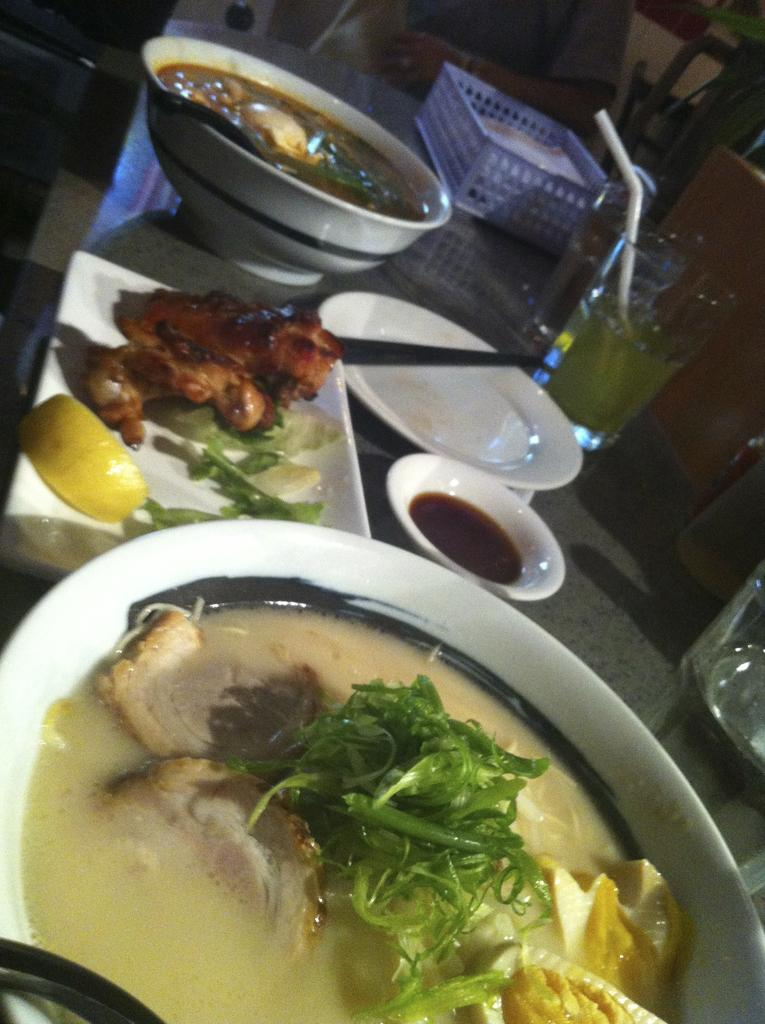What type of soup is in the image? There is meat soup in the image. What additional ingredients are in the meat soup? The meat soup contains leaves. What other food items can be seen in the image? There are fried meat pieces and bowls with food in the image. What type of container is present for drinking? There is a glass in the image. What object is on the table in the image? There is a basket on the table in the image. What type of skin can be seen on the table in the image? There is no skin visible on the table in the image. What type of bedroom furniture is present in the image? There is no bedroom furniture present in the image; it features a table with various food items and a basket. 